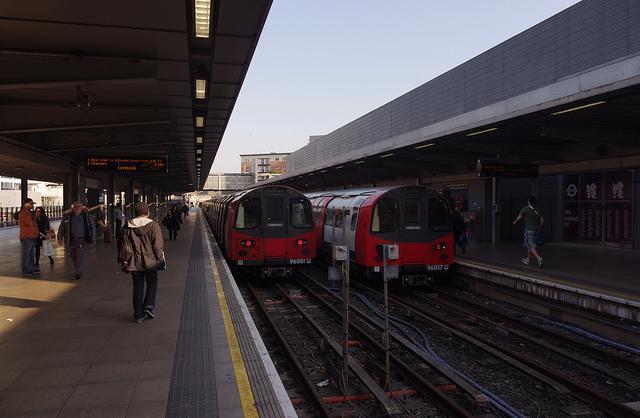How many trains are there?
Give a very brief answer. 2. How many trains are here?
Give a very brief answer. 2. How many tracks are there?
Give a very brief answer. 2. How many trains are visible?
Give a very brief answer. 2. How many giraffes are there?
Give a very brief answer. 0. 